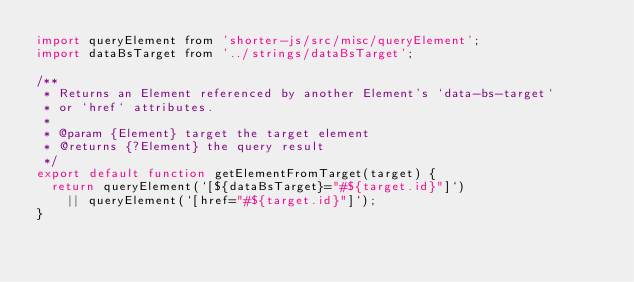<code> <loc_0><loc_0><loc_500><loc_500><_JavaScript_>import queryElement from 'shorter-js/src/misc/queryElement';
import dataBsTarget from '../strings/dataBsTarget';

/**
 * Returns an Element referenced by another Element's `data-bs-target`
 * or `href` attributes.
 *
 * @param {Element} target the target element
 * @returns {?Element} the query result
 */
export default function getElementFromTarget(target) {
  return queryElement(`[${dataBsTarget}="#${target.id}"]`)
    || queryElement(`[href="#${target.id}"]`);
}
</code> 